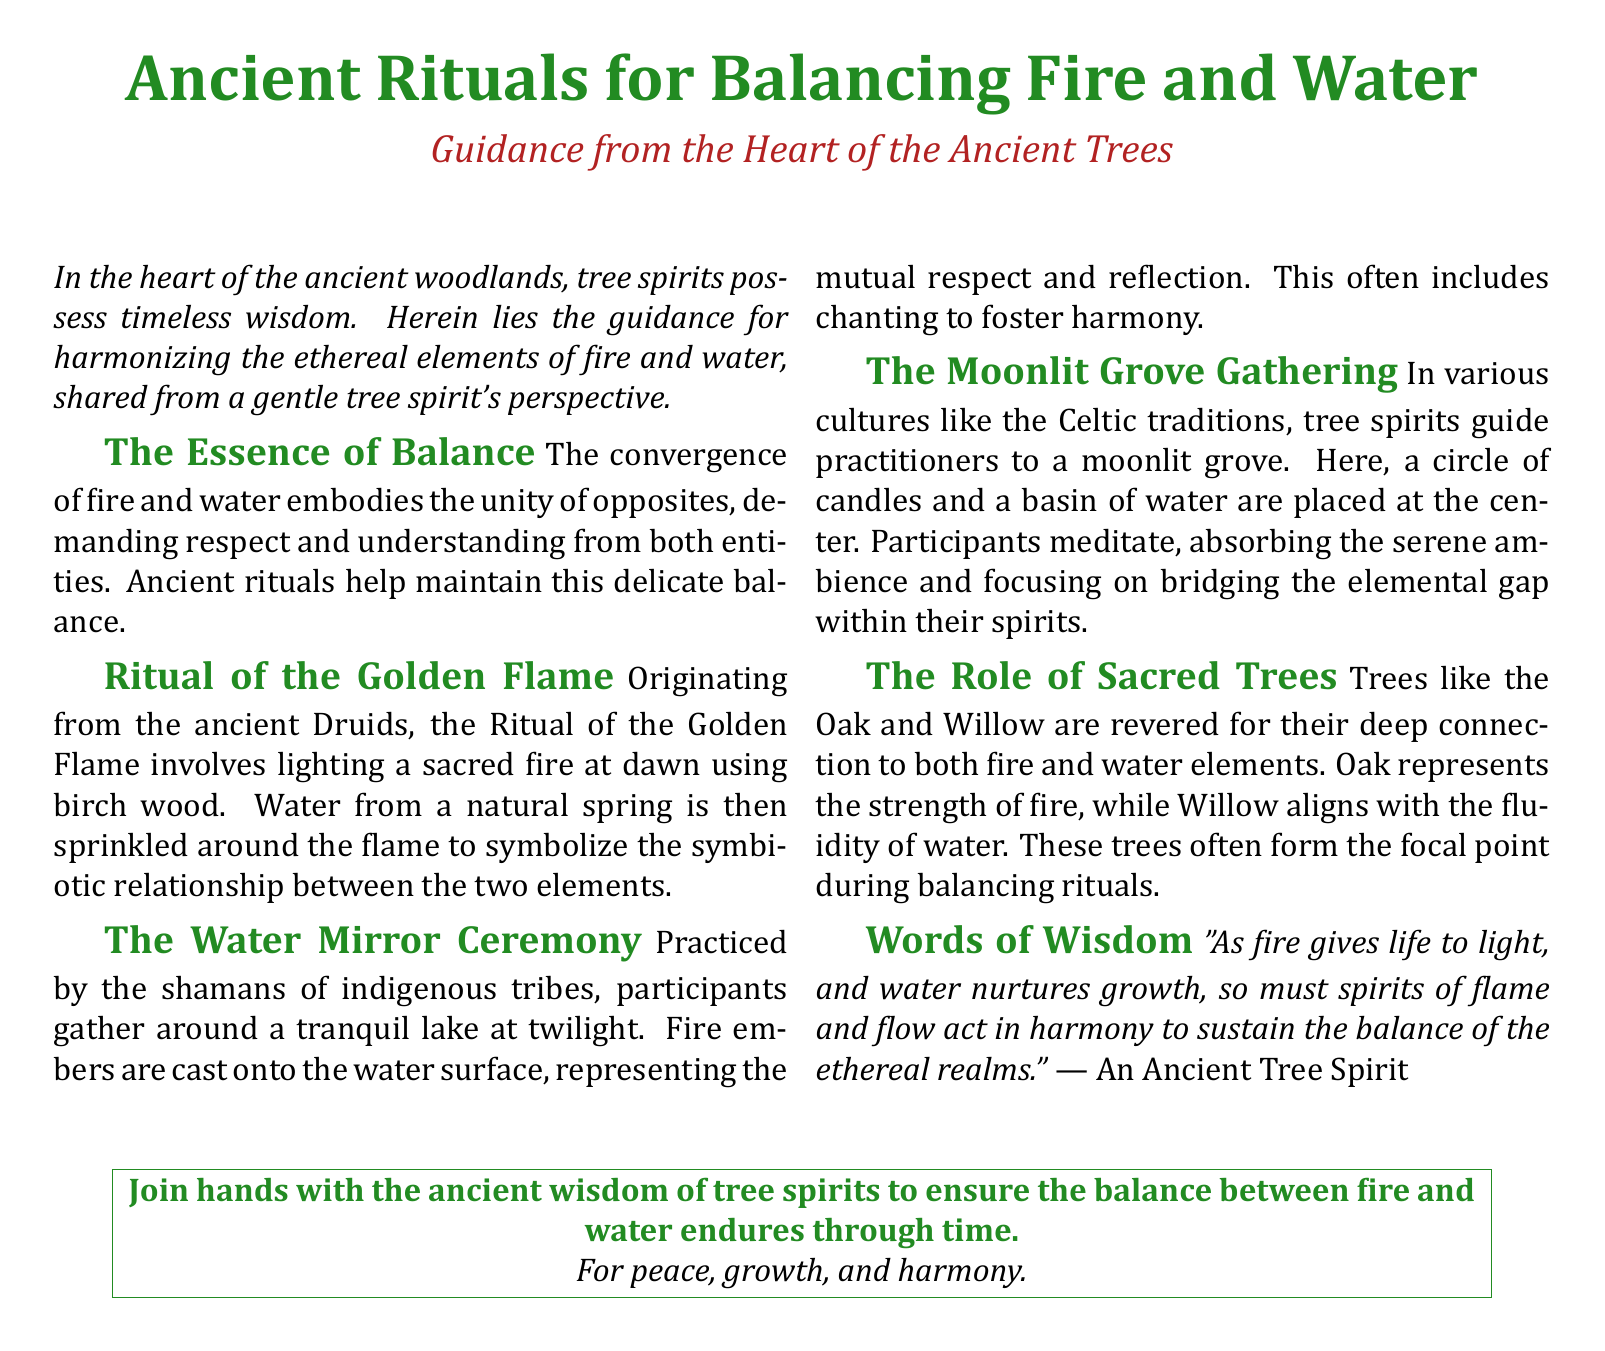What is the title of the document? The title is the main heading at the top of the document.
Answer: Ancient Rituals for Balancing Fire and Water Who provides guidance in the document? The guidance is attributed to a specific entity mentioned in the document.
Answer: A gentle tree spirit What wood is used in the Ritual of the Golden Flame? This wood is specifically highlighted as part of an ancient ritual mentioned in the document.
Answer: Birch What is cast onto the water surface during The Water Mirror Ceremony? This action is described in the context of a specific ritual practiced by shamans.
Answer: Fire embers Which trees are mentioned as sacred? The document specifically states two trees related to the elements of fire and water.
Answer: Oak and Willow What time of day does the Ritual of the Golden Flame occur? This detail is part of the description of the ritual in the document.
Answer: Dawn What element does the Oak tree represent? The document describes the symbolic meaning associated with the Oak tree.
Answer: Strength of fire What do participants focus on during The Moonlit Grove Gathering? This phrase summarizes the intent of the gathering as mentioned in the document.
Answer: Bridging the elemental gap What is emphasized as necessary for maintaining balance? This concept is encapsulated in a direct quotation in the document.
Answer: Harmony 